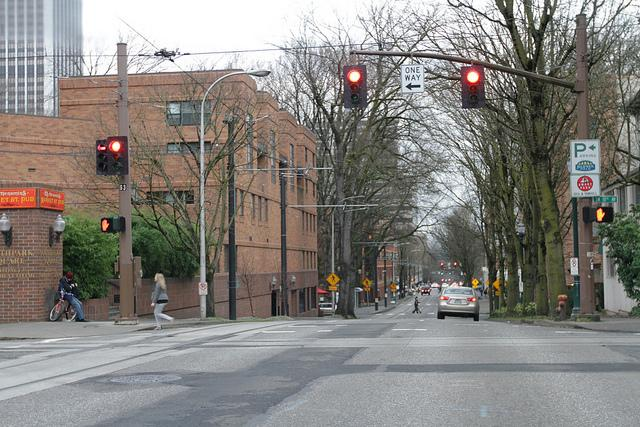Where do you think this is located?

Choices:
A) countryside
B) farm
C) school
D) city city 